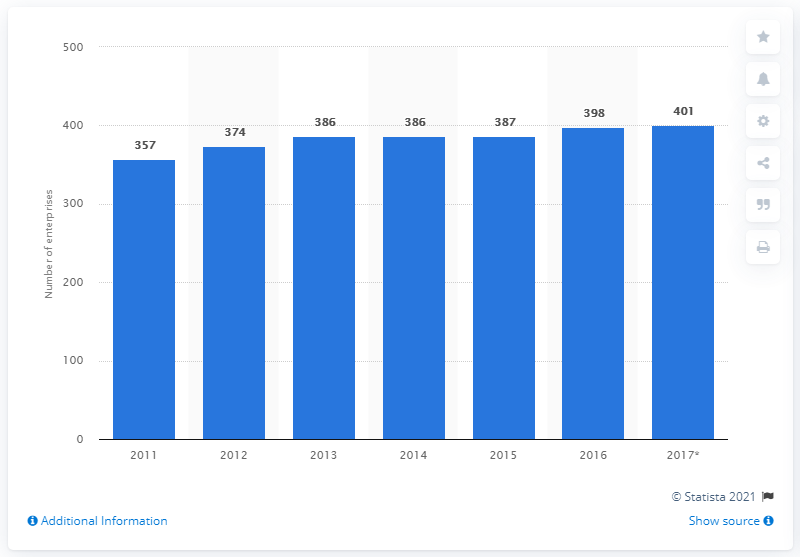Draw attention to some important aspects in this diagram. In 2017, there were 401 enterprises in North Macedonia that manufactured plastics products. 